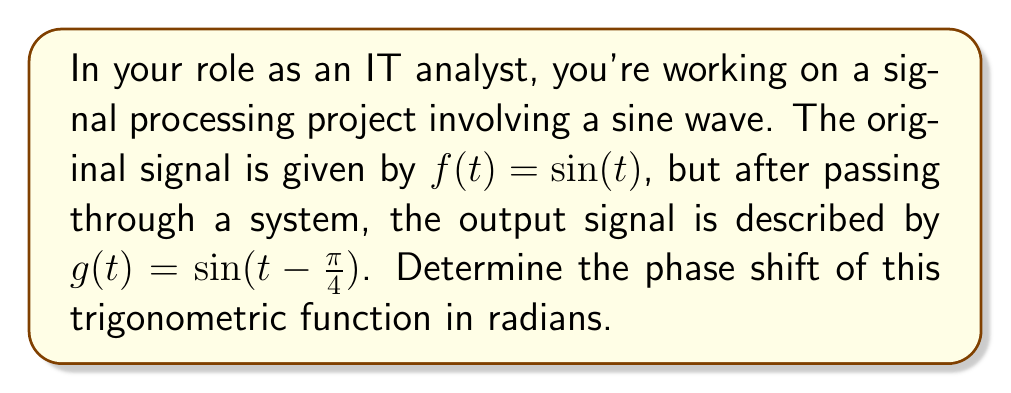Help me with this question. To determine the phase shift of a trigonometric function, we need to compare the modified function to the standard form. 

1. The standard form of a sine function is:
   $$f(t) = A\sin(B(t - C)) + D$$
   where $C$ represents the phase shift.

2. In our case, we have:
   $$g(t) = \sin(t - \frac{\pi}{4})$$

3. Comparing this to the standard form, we can identify:
   $A = 1$ (amplitude)
   $B = 1$ (frequency)
   $C = \frac{\pi}{4}$ (phase shift)
   $D = 0$ (vertical shift)

4. The phase shift is the value of $C$, which is $\frac{\pi}{4}$ radians.

5. In signal processing, a positive value inside the parentheses $(t - \frac{\pi}{4})$ indicates a shift to the right, or a delay in the signal. Therefore, our signal is shifted $\frac{\pi}{4}$ radians to the right.

This phase shift can be visualized as a horizontal translation of the original sine wave by $\frac{\pi}{4}$ units to the right on the t-axis.
Answer: The phase shift is $\frac{\pi}{4}$ radians to the right. 